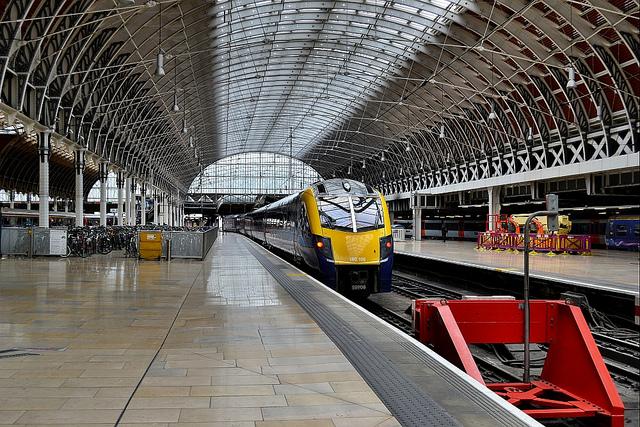Is there a train on the track?
Quick response, please. Yes. Is this building used for transportation?
Keep it brief. Yes. Where is this?
Be succinct. Train station. 